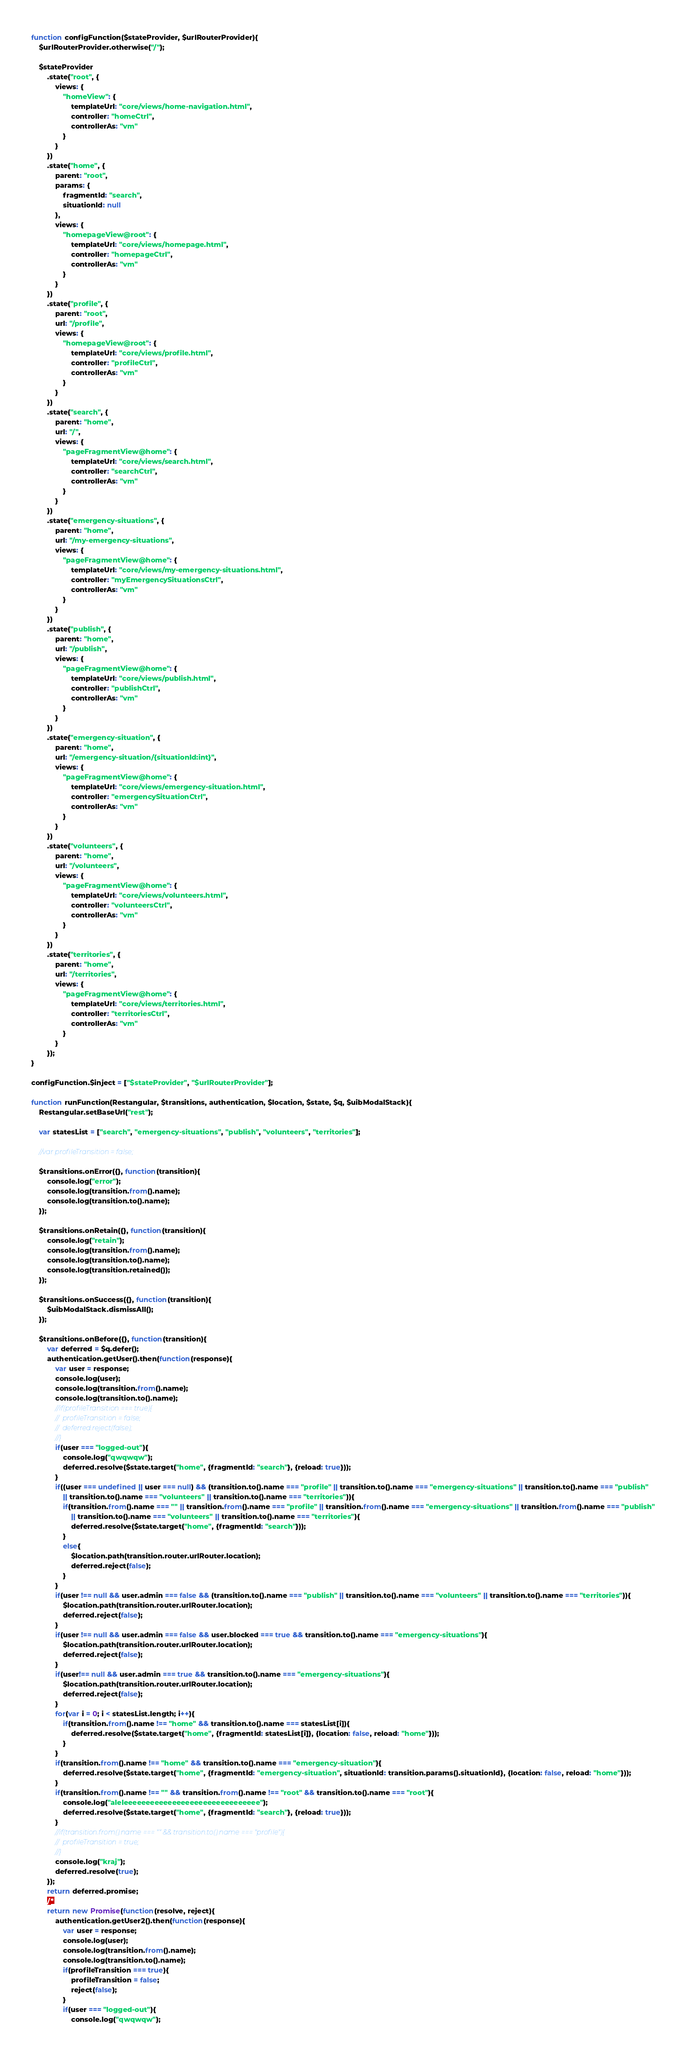<code> <loc_0><loc_0><loc_500><loc_500><_JavaScript_>	
	function configFunction($stateProvider, $urlRouterProvider){
		$urlRouterProvider.otherwise("/");
		
		$stateProvider
			.state("root", {
				views: {
					"homeView": {
						templateUrl: "core/views/home-navigation.html",
						controller: "homeCtrl",
						controllerAs: "vm"
					}
				}
			})
			.state("home", {
				parent: "root",
				params: {
					fragmentId: "search",
					situationId: null
				},
				views: {
					"homepageView@root": {
						templateUrl: "core/views/homepage.html",
						controller: "homepageCtrl",
						controllerAs: "vm"
					}
				}
			})
			.state("profile", {
				parent: "root",
				url: "/profile",
				views: {
					"homepageView@root": {
						templateUrl: "core/views/profile.html",
						controller: "profileCtrl",
						controllerAs: "vm"
					}
				}
			})
			.state("search", {
				parent: "home",
				url: "/",
				views: {
					"pageFragmentView@home": {
						templateUrl: "core/views/search.html",
						controller: "searchCtrl",
						controllerAs: "vm"
					}
				}
			})
			.state("emergency-situations", {
				parent: "home",
				url: "/my-emergency-situations",
				views: {
					"pageFragmentView@home": {
						templateUrl: "core/views/my-emergency-situations.html",
						controller: "myEmergencySituationsCtrl",
						controllerAs: "vm"
					}
				}
			})
			.state("publish", {
				parent: "home",
				url: "/publish",
				views: {
					"pageFragmentView@home": {
						templateUrl: "core/views/publish.html",
						controller: "publishCtrl",
						controllerAs: "vm"
					}
				}
			})
			.state("emergency-situation", {
				parent: "home",
				url: "/emergency-situation/{situationId:int}",
				views: {
					"pageFragmentView@home": {
						templateUrl: "core/views/emergency-situation.html",
						controller: "emergencySituationCtrl",
						controllerAs: "vm"
					}
				}
			})
			.state("volunteers", {
				parent: "home",
				url: "/volunteers",
				views: {
					"pageFragmentView@home": {
						templateUrl: "core/views/volunteers.html",
						controller: "volunteersCtrl",
						controllerAs: "vm"
					}
				}
			})
			.state("territories", {
				parent: "home",
				url: "/territories",
				views: {
					"pageFragmentView@home": {
						templateUrl: "core/views/territories.html",
						controller: "territoriesCtrl",
						controllerAs: "vm"
					}
				}
			});
	}
	
	configFunction.$inject = ["$stateProvider", "$urlRouterProvider"];
	
	function runFunction(Restangular, $transitions, authentication, $location, $state, $q, $uibModalStack){
		Restangular.setBaseUrl("rest");
		
		var statesList = ["search", "emergency-situations", "publish", "volunteers", "territories"];
		
		//var profileTransition = false;
		
		$transitions.onError({}, function(transition){
			console.log("error");
			console.log(transition.from().name);
			console.log(transition.to().name);
		});
		
		$transitions.onRetain({}, function(transition){
			console.log("retain");
			console.log(transition.from().name);
			console.log(transition.to().name);
			console.log(transition.retained());
		});
		
		$transitions.onSuccess({}, function(transition){
			$uibModalStack.dismissAll();
		});
		
		$transitions.onBefore({}, function(transition){
			var deferred = $q.defer();
			authentication.getUser().then(function(response){
				var user = response;
				console.log(user);
				console.log(transition.from().name);
				console.log(transition.to().name);
				//if(profileTransition === true){
				//	profileTransition = false;
				//	deferred.reject(false);
				//}
				if(user === "logged-out"){
					console.log("qwqwqw");
					deferred.resolve($state.target("home", {fragmentId: "search"}, {reload: true}));
				}
				if((user === undefined || user === null) && (transition.to().name === "profile" || transition.to().name === "emergency-situations" || transition.to().name === "publish" 
					|| transition.to().name === "volunteers" || transition.to().name === "territories")){
					if(transition.from().name === "" || transition.from().name === "profile" || transition.from().name === "emergency-situations" || transition.from().name === "publish" 
						|| transition.to().name === "volunteers" || transition.to().name === "territories"){
						deferred.resolve($state.target("home", {fragmentId: "search"}));
					}
					else{
						$location.path(transition.router.urlRouter.location);
						deferred.reject(false);
					}
				}
				if(user !== null && user.admin === false && (transition.to().name === "publish" || transition.to().name === "volunteers" || transition.to().name === "territories")){
					$location.path(transition.router.urlRouter.location);
					deferred.reject(false);
				}
				if(user !== null && user.admin === false && user.blocked === true && transition.to().name === "emergency-situations"){
					$location.path(transition.router.urlRouter.location);
					deferred.reject(false);
				}
				if(user!== null && user.admin === true && transition.to().name === "emergency-situations"){
					$location.path(transition.router.urlRouter.location);
					deferred.reject(false);
				}
				for(var i = 0; i < statesList.length; i++){
					if(transition.from().name !== "home" && transition.to().name === statesList[i]){
						deferred.resolve($state.target("home", {fragmentId: statesList[i]}, {location: false, reload: "home"}));
					}
				}
				if(transition.from().name !== "home" && transition.to().name === "emergency-situation"){
					deferred.resolve($state.target("home", {fragmentId: "emergency-situation", situationId: transition.params().situationId}, {location: false, reload: "home"}));
				}
				if(transition.from().name !== "" && transition.from().name !== "root" && transition.to().name === "root"){
					console.log("aleleeeeeeeeeeeeeeeeeeeeeeeeeeeeeee");
					deferred.resolve($state.target("home", {fragmentId: "search"}, {reload: true}));
				}
				//if(transition.from().name === "" && transition.to().name === "profile"){
				//	profileTransition = true;
				//}
				console.log("kraj");
				deferred.resolve(true);
			});
			return deferred.promise;
			/*
			return new Promise(function(resolve, reject){
				authentication.getUser2().then(function(response){
					var user = response;
					console.log(user);
					console.log(transition.from().name);
					console.log(transition.to().name);
					if(profileTransition === true){
						profileTransition = false;
						reject(false);
					}
					if(user === "logged-out"){
						console.log("qwqwqw");</code> 